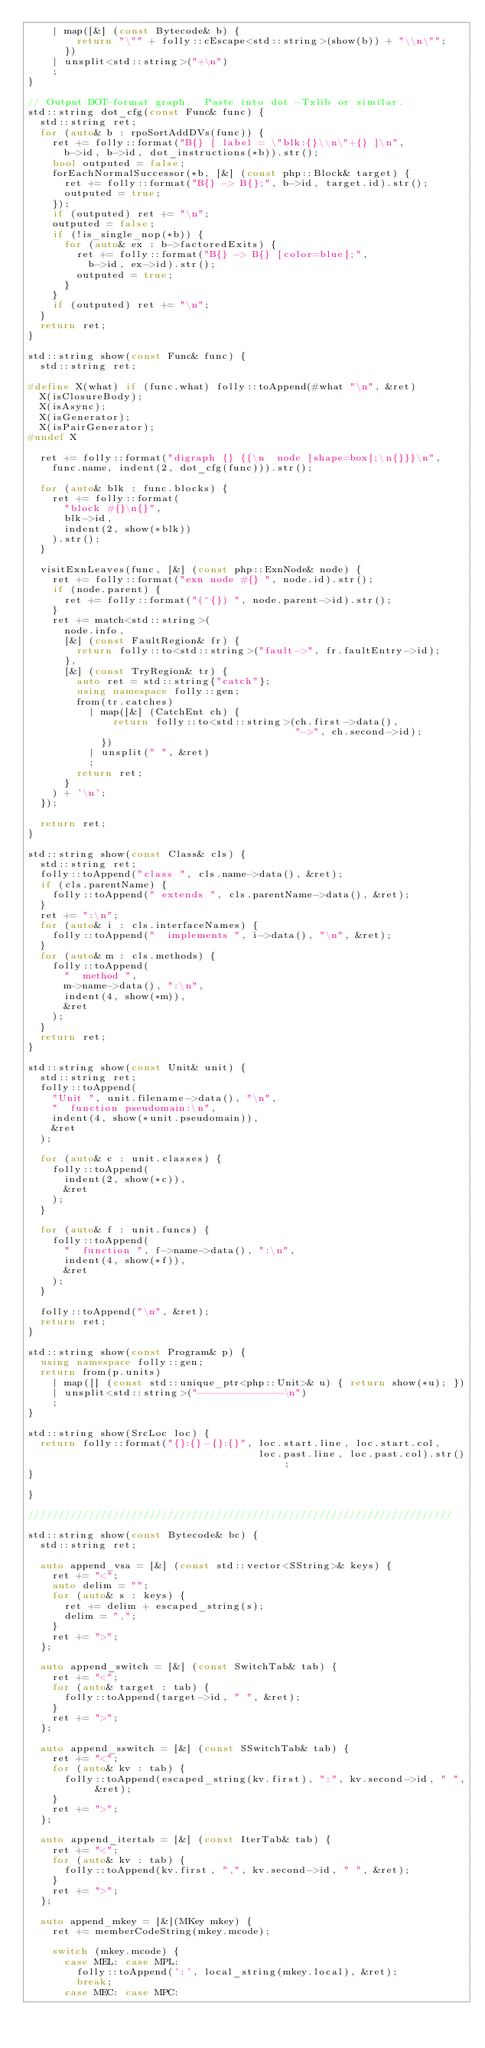<code> <loc_0><loc_0><loc_500><loc_500><_C++_>    | map([&] (const Bytecode& b) {
        return "\"" + folly::cEscape<std::string>(show(b)) + "\\n\"";
      })
    | unsplit<std::string>("+\n")
    ;
}

// Output DOT-format graph.  Paste into dot -Txlib or similar.
std::string dot_cfg(const Func& func) {
  std::string ret;
  for (auto& b : rpoSortAddDVs(func)) {
    ret += folly::format("B{} [ label = \"blk:{}\\n\"+{} ]\n",
      b->id, b->id, dot_instructions(*b)).str();
    bool outputed = false;
    forEachNormalSuccessor(*b, [&] (const php::Block& target) {
      ret += folly::format("B{} -> B{};", b->id, target.id).str();
      outputed = true;
    });
    if (outputed) ret += "\n";
    outputed = false;
    if (!is_single_nop(*b)) {
      for (auto& ex : b->factoredExits) {
        ret += folly::format("B{} -> B{} [color=blue];",
          b->id, ex->id).str();
        outputed = true;
      }
    }
    if (outputed) ret += "\n";
  }
  return ret;
}

std::string show(const Func& func) {
  std::string ret;

#define X(what) if (func.what) folly::toAppend(#what "\n", &ret)
  X(isClosureBody);
  X(isAsync);
  X(isGenerator);
  X(isPairGenerator);
#undef X

  ret += folly::format("digraph {} {{\n  node [shape=box];\n{}}}\n",
    func.name, indent(2, dot_cfg(func))).str();

  for (auto& blk : func.blocks) {
    ret += folly::format(
      "block #{}\n{}",
      blk->id,
      indent(2, show(*blk))
    ).str();
  }

  visitExnLeaves(func, [&] (const php::ExnNode& node) {
    ret += folly::format("exn node #{} ", node.id).str();
    if (node.parent) {
      ret += folly::format("(^{}) ", node.parent->id).str();
    }
    ret += match<std::string>(
      node.info,
      [&] (const FaultRegion& fr) {
        return folly::to<std::string>("fault->", fr.faultEntry->id);
      },
      [&] (const TryRegion& tr) {
        auto ret = std::string{"catch"};
        using namespace folly::gen;
        from(tr.catches)
          | map([&] (CatchEnt ch) {
              return folly::to<std::string>(ch.first->data(),
                                            "->", ch.second->id);
            })
          | unsplit(" ", &ret)
          ;
        return ret;
      }
    ) + '\n';
  });

  return ret;
}

std::string show(const Class& cls) {
  std::string ret;
  folly::toAppend("class ", cls.name->data(), &ret);
  if (cls.parentName) {
    folly::toAppend(" extends ", cls.parentName->data(), &ret);
  }
  ret += ":\n";
  for (auto& i : cls.interfaceNames) {
    folly::toAppend("  implements ", i->data(), "\n", &ret);
  }
  for (auto& m : cls.methods) {
    folly::toAppend(
      "  method ",
      m->name->data(), ":\n",
      indent(4, show(*m)),
      &ret
    );
  }
  return ret;
}

std::string show(const Unit& unit) {
  std::string ret;
  folly::toAppend(
    "Unit ", unit.filename->data(), "\n",
    "  function pseudomain:\n",
    indent(4, show(*unit.pseudomain)),
    &ret
  );

  for (auto& c : unit.classes) {
    folly::toAppend(
      indent(2, show(*c)),
      &ret
    );
  }

  for (auto& f : unit.funcs) {
    folly::toAppend(
      "  function ", f->name->data(), ":\n",
      indent(4, show(*f)),
      &ret
    );
  }

  folly::toAppend("\n", &ret);
  return ret;
}

std::string show(const Program& p) {
  using namespace folly::gen;
  return from(p.units)
    | map([] (const std::unique_ptr<php::Unit>& u) { return show(*u); })
    | unsplit<std::string>("--------------\n")
    ;
}

std::string show(SrcLoc loc) {
  return folly::format("{}:{}-{}:{}", loc.start.line, loc.start.col,
                                      loc.past.line, loc.past.col).str();
}

}

//////////////////////////////////////////////////////////////////////

std::string show(const Bytecode& bc) {
  std::string ret;

  auto append_vsa = [&] (const std::vector<SString>& keys) {
    ret += "<";
    auto delim = "";
    for (auto& s : keys) {
      ret += delim + escaped_string(s);
      delim = ",";
    }
    ret += ">";
  };

  auto append_switch = [&] (const SwitchTab& tab) {
    ret += "<";
    for (auto& target : tab) {
      folly::toAppend(target->id, " ", &ret);
    }
    ret += ">";
  };

  auto append_sswitch = [&] (const SSwitchTab& tab) {
    ret += "<";
    for (auto& kv : tab) {
      folly::toAppend(escaped_string(kv.first), ":", kv.second->id, " ", &ret);
    }
    ret += ">";
  };

  auto append_itertab = [&] (const IterTab& tab) {
    ret += "<";
    for (auto& kv : tab) {
      folly::toAppend(kv.first, ",", kv.second->id, " ", &ret);
    }
    ret += ">";
  };

  auto append_mkey = [&](MKey mkey) {
    ret += memberCodeString(mkey.mcode);

    switch (mkey.mcode) {
      case MEL: case MPL:
        folly::toAppend(':', local_string(mkey.local), &ret);
        break;
      case MEC: case MPC:</code> 